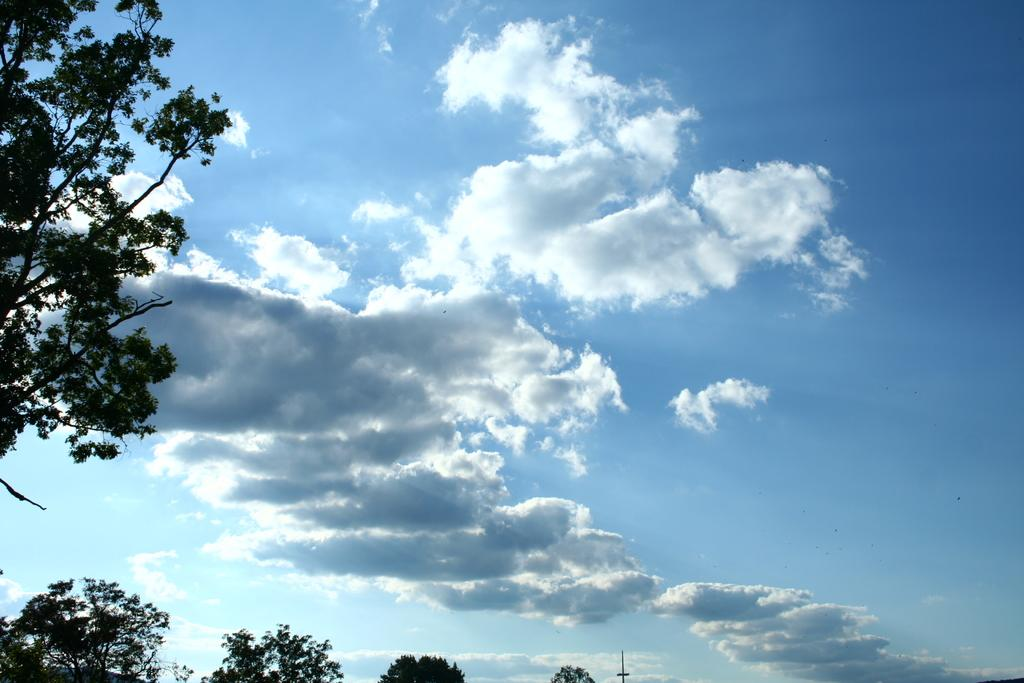What can be seen at the top of the image? The sky is visible in the image. What is present in the sky? There are clouds in the sky. What is located at the bottom of the image? There are trees and a pole at the bottom of the image. What type of dinner is being served in the image? There is no dinner present in the image; it only features the sky, clouds, trees, and a pole. What act are the trees performing in the image? The trees are not performing any act in the image; they are simply standing in their natural state. 